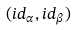Convert formula to latex. <formula><loc_0><loc_0><loc_500><loc_500>( i d _ { \alpha } , i d _ { \beta } )</formula> 